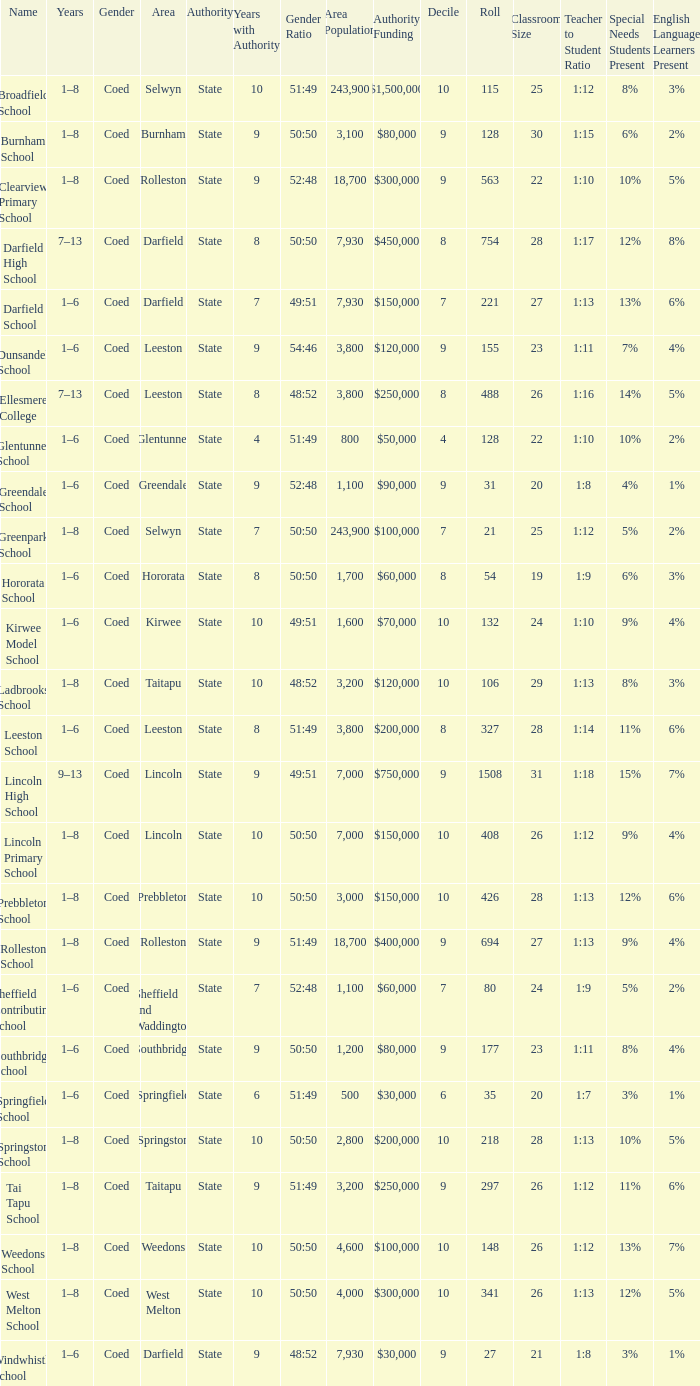Which name has a Roll larger than 297, and Years of 7–13? Darfield High School, Ellesmere College. 